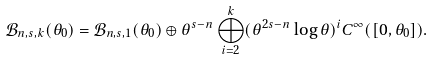<formula> <loc_0><loc_0><loc_500><loc_500>\mathcal { B } _ { n , s , k } ( \theta _ { 0 } ) = \mathcal { B } _ { n , s , 1 } ( \theta _ { 0 } ) \oplus \theta ^ { s - n } \bigoplus _ { i = 2 } ^ { k } ( \theta ^ { 2 s - n } \log \theta ) ^ { i } C ^ { \infty } ( [ 0 , \theta _ { 0 } ] ) .</formula> 